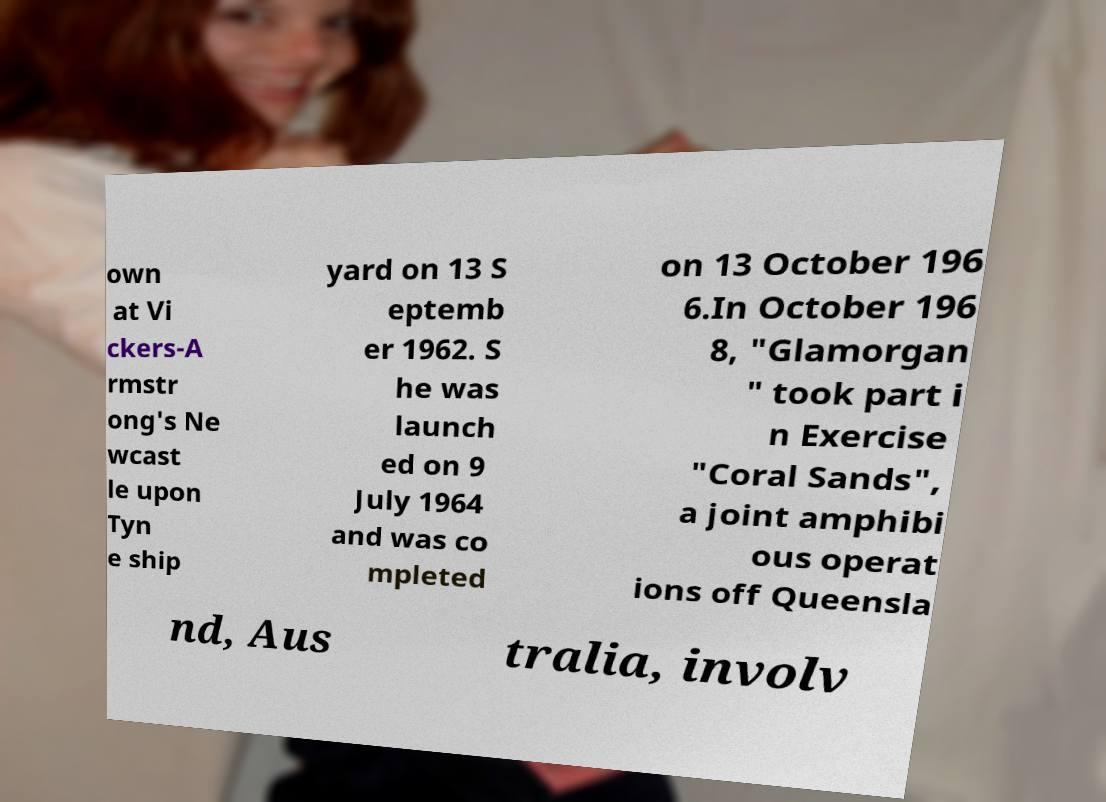There's text embedded in this image that I need extracted. Can you transcribe it verbatim? own at Vi ckers-A rmstr ong's Ne wcast le upon Tyn e ship yard on 13 S eptemb er 1962. S he was launch ed on 9 July 1964 and was co mpleted on 13 October 196 6.In October 196 8, "Glamorgan " took part i n Exercise "Coral Sands", a joint amphibi ous operat ions off Queensla nd, Aus tralia, involv 